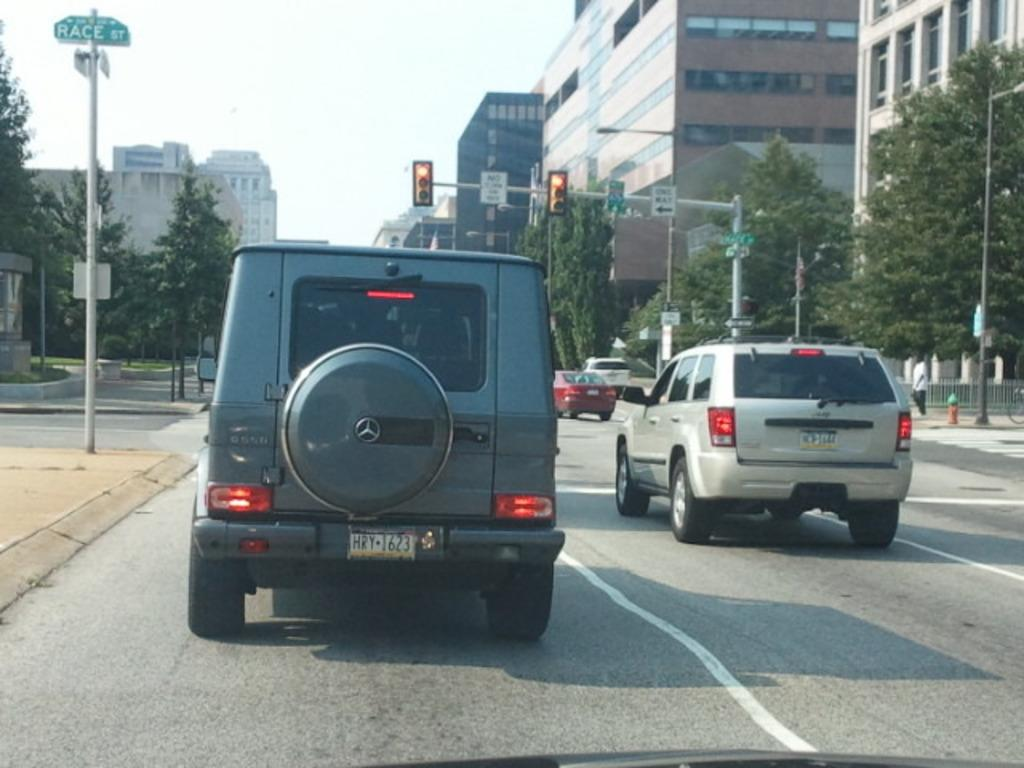What can be seen on the road in the image? There are vehicles on the road in the image. What structures are present in the image? Poles, traffic signals, direction boards, trees, buildings, and some objects are visible in the image. What might help guide the vehicles on the road? Traffic signals and direction boards are present in the image to guide the vehicles. What is visible in the background of the image? The sky is visible in the background of the image. What type of competition is taking place in the image? There is no competition present in the image; it features vehicles on the road, poles, traffic signals, direction boards, trees, buildings, objects, and the sky. What answer can be found on the development in the image? There is no development or answer present in the image; it is a scene of vehicles on the road, poles, traffic signals, direction boards, trees, buildings, objects, and the sky. 